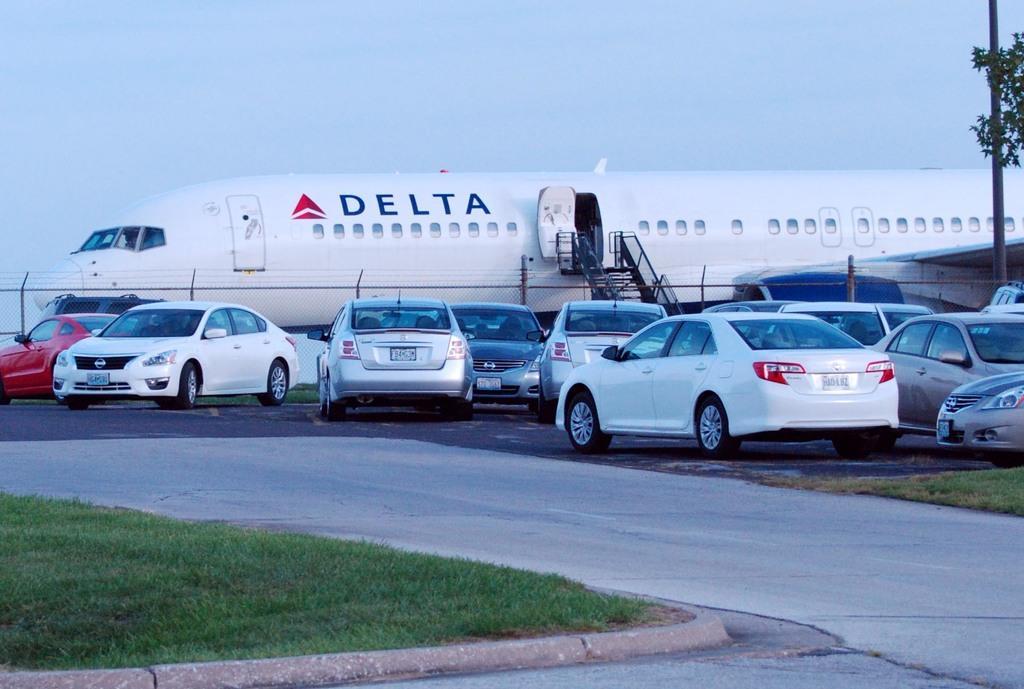How would you summarize this image in a sentence or two? In this image there are cars on a road, on either side of the road there is grassland, in the background there is fencing and an airplane and the sky. 